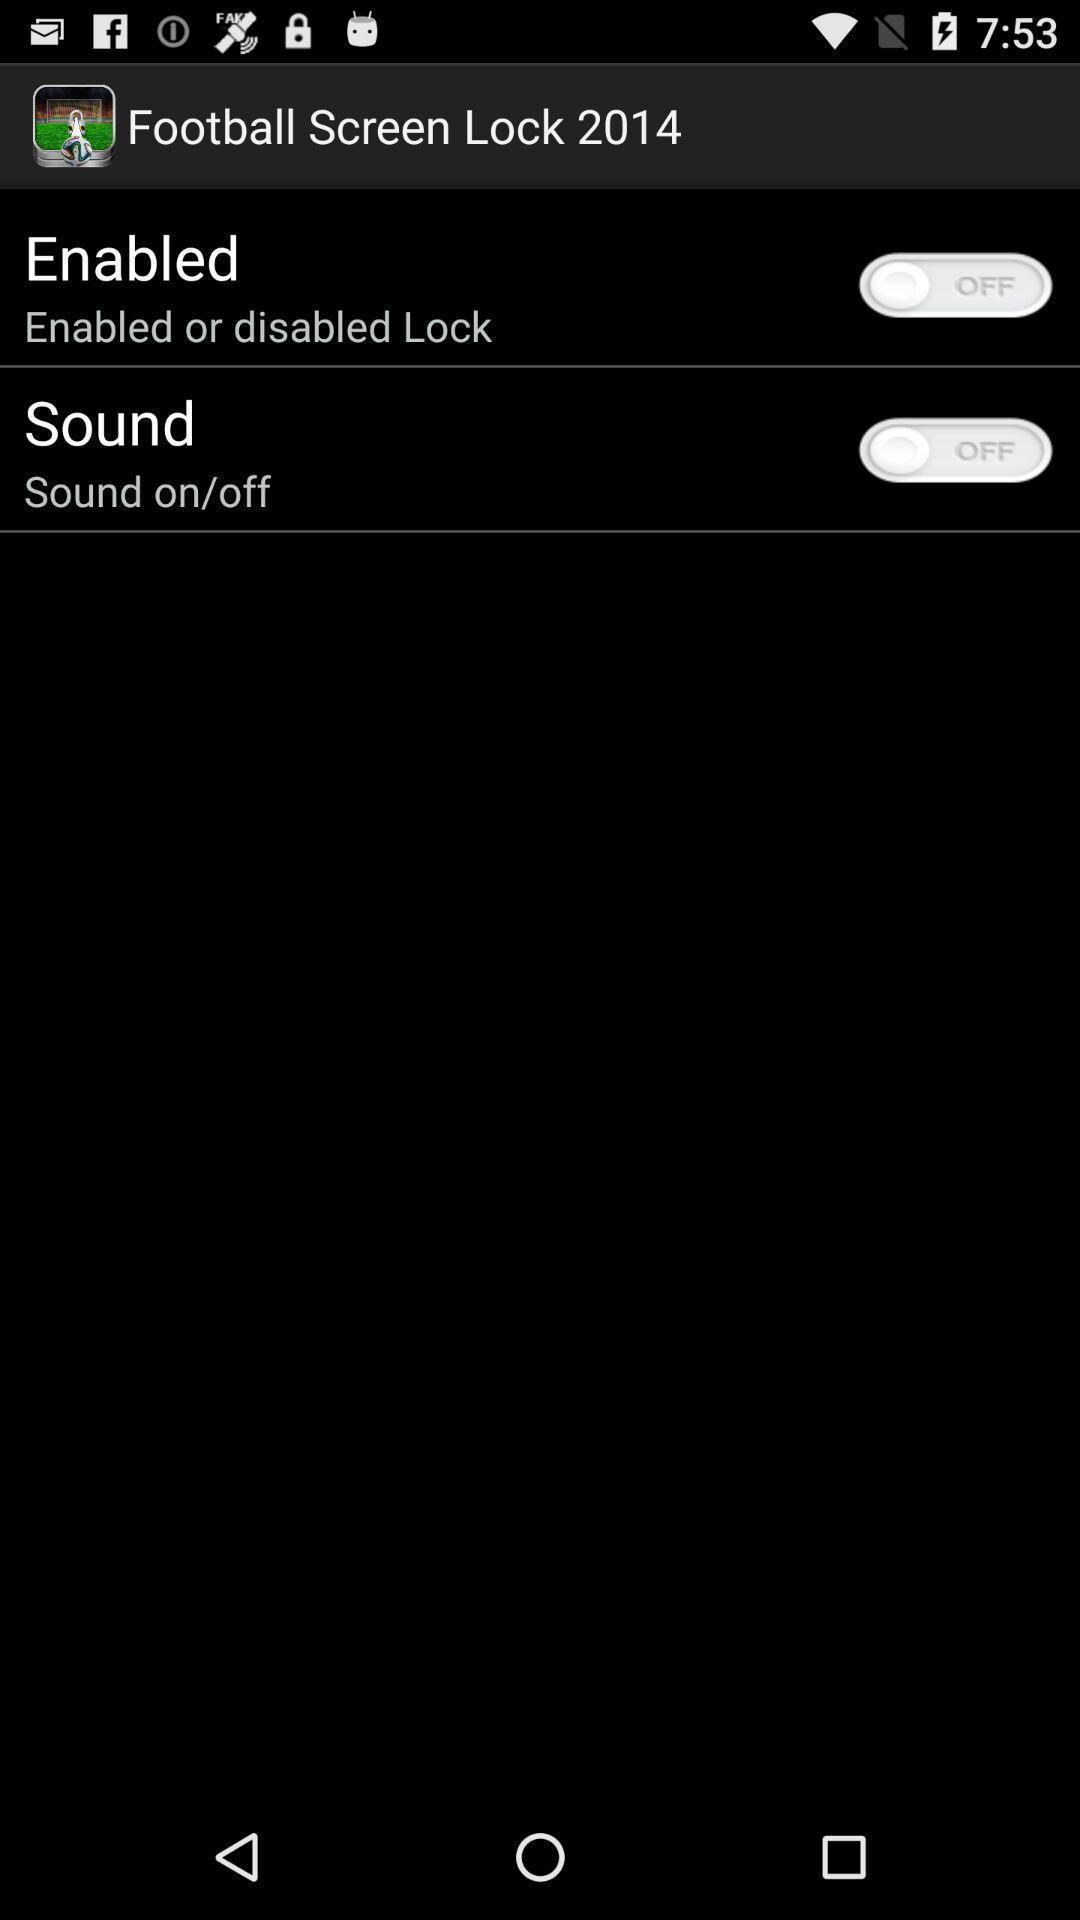Provide a description of this screenshot. Screen page showing multiple options in gaming application. 